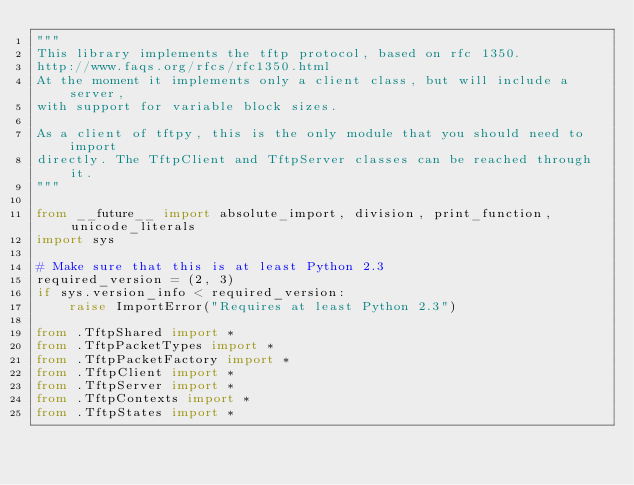Convert code to text. <code><loc_0><loc_0><loc_500><loc_500><_Python_>"""
This library implements the tftp protocol, based on rfc 1350.
http://www.faqs.org/rfcs/rfc1350.html
At the moment it implements only a client class, but will include a server,
with support for variable block sizes.

As a client of tftpy, this is the only module that you should need to import
directly. The TftpClient and TftpServer classes can be reached through it.
"""

from __future__ import absolute_import, division, print_function, unicode_literals
import sys

# Make sure that this is at least Python 2.3
required_version = (2, 3)
if sys.version_info < required_version:
    raise ImportError("Requires at least Python 2.3")

from .TftpShared import *
from .TftpPacketTypes import *
from .TftpPacketFactory import *
from .TftpClient import *
from .TftpServer import *
from .TftpContexts import *
from .TftpStates import *

</code> 